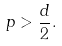<formula> <loc_0><loc_0><loc_500><loc_500>p > \frac { d } { 2 } .</formula> 